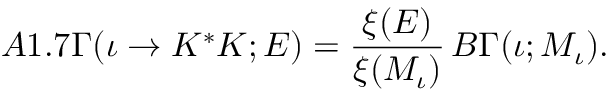Convert formula to latex. <formula><loc_0><loc_0><loc_500><loc_500>A 1 . 7 \Gamma ( \iota \rightarrow K ^ { * } K ; E ) = \frac { \xi ( E ) } { \xi ( M _ { \iota } ) } \, B \Gamma ( \iota ; M _ { \iota } ) .</formula> 